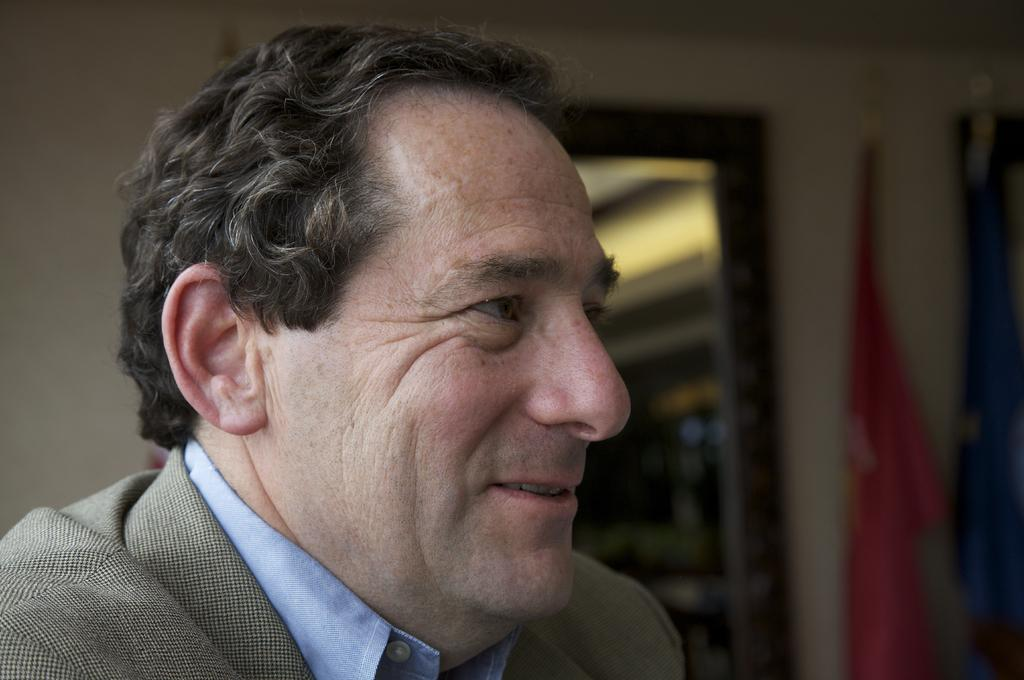Who is present in the image? There is a man in the image. What is the man wearing? The man is wearing a suit and a blue shirt. What can be seen in the background of the image? There is a wall and a window in the background of the image. What is hung on the wall to the right? Clothes are hanged on the wall to the right. What type of haircut does the man have in the image? The provided facts do not mention the man's haircut, so it cannot be determined from the image. Can you tell me if the man received approval for his outfit in the image? There is no indication in the image or the provided facts about whether the man received approval for his outfit. 